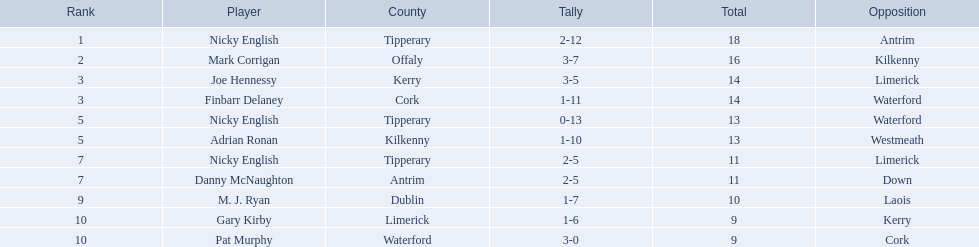From the provided players, who were placed in the bottom 5 rankings? Nicky English, Danny McNaughton, M. J. Ryan, Gary Kirby, Pat Murphy. Of those, who had scores other than 2-5? M. J. Ryan, Gary Kirby, Pat Murphy. From the selected three, which player had a total score higher than 9 points? M. J. Ryan. 